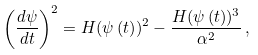Convert formula to latex. <formula><loc_0><loc_0><loc_500><loc_500>\left ( \frac { d \psi } { d t } \right ) ^ { 2 } = H ( \psi \left ( t \right ) ) ^ { 2 } - \frac { H ( \psi \left ( t \right ) ) ^ { 3 } } { \alpha ^ { 2 } } \, ,</formula> 